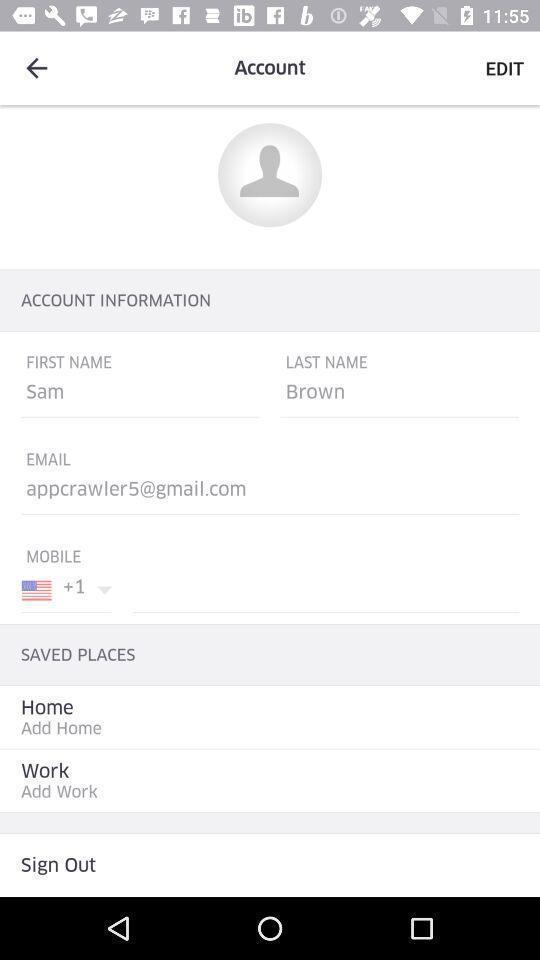Explain what's happening in this screen capture. Page displaying the create a account details. 